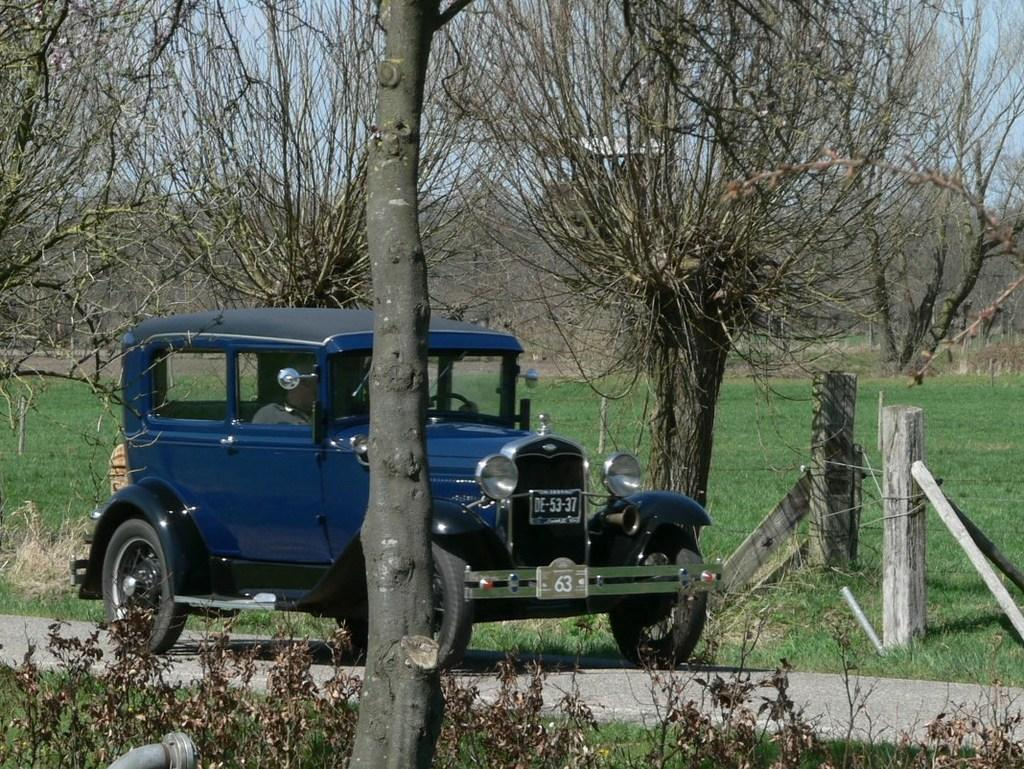What type of car is in the image? There is a blue color classic car in the image. Where is the car located? The car is on the road. What can be seen behind the car? There are dry trees and a grass lawn behind the car. What is visible in the front of the image? There are dry plants and a tree trunk in the front of the image. What type of teeth can be seen on the scarecrow in the image? There is no scarecrow present in the image, so there are no teeth to be seen. 